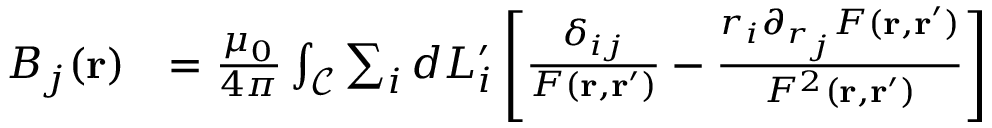<formula> <loc_0><loc_0><loc_500><loc_500>\begin{array} { r l } { B _ { j } ( r ) } & { = \frac { \mu _ { 0 } } { 4 \pi } \int _ { \mathcal { C } } \sum _ { i } d L _ { i } ^ { \prime } \left [ \frac { \delta _ { i j } } { F ( r , r ^ { \prime } ) } - \frac { r _ { i } \partial _ { r _ { j } } F ( r , r ^ { \prime } ) } { F ^ { 2 } ( r , r ^ { \prime } ) } \right ] } \end{array}</formula> 